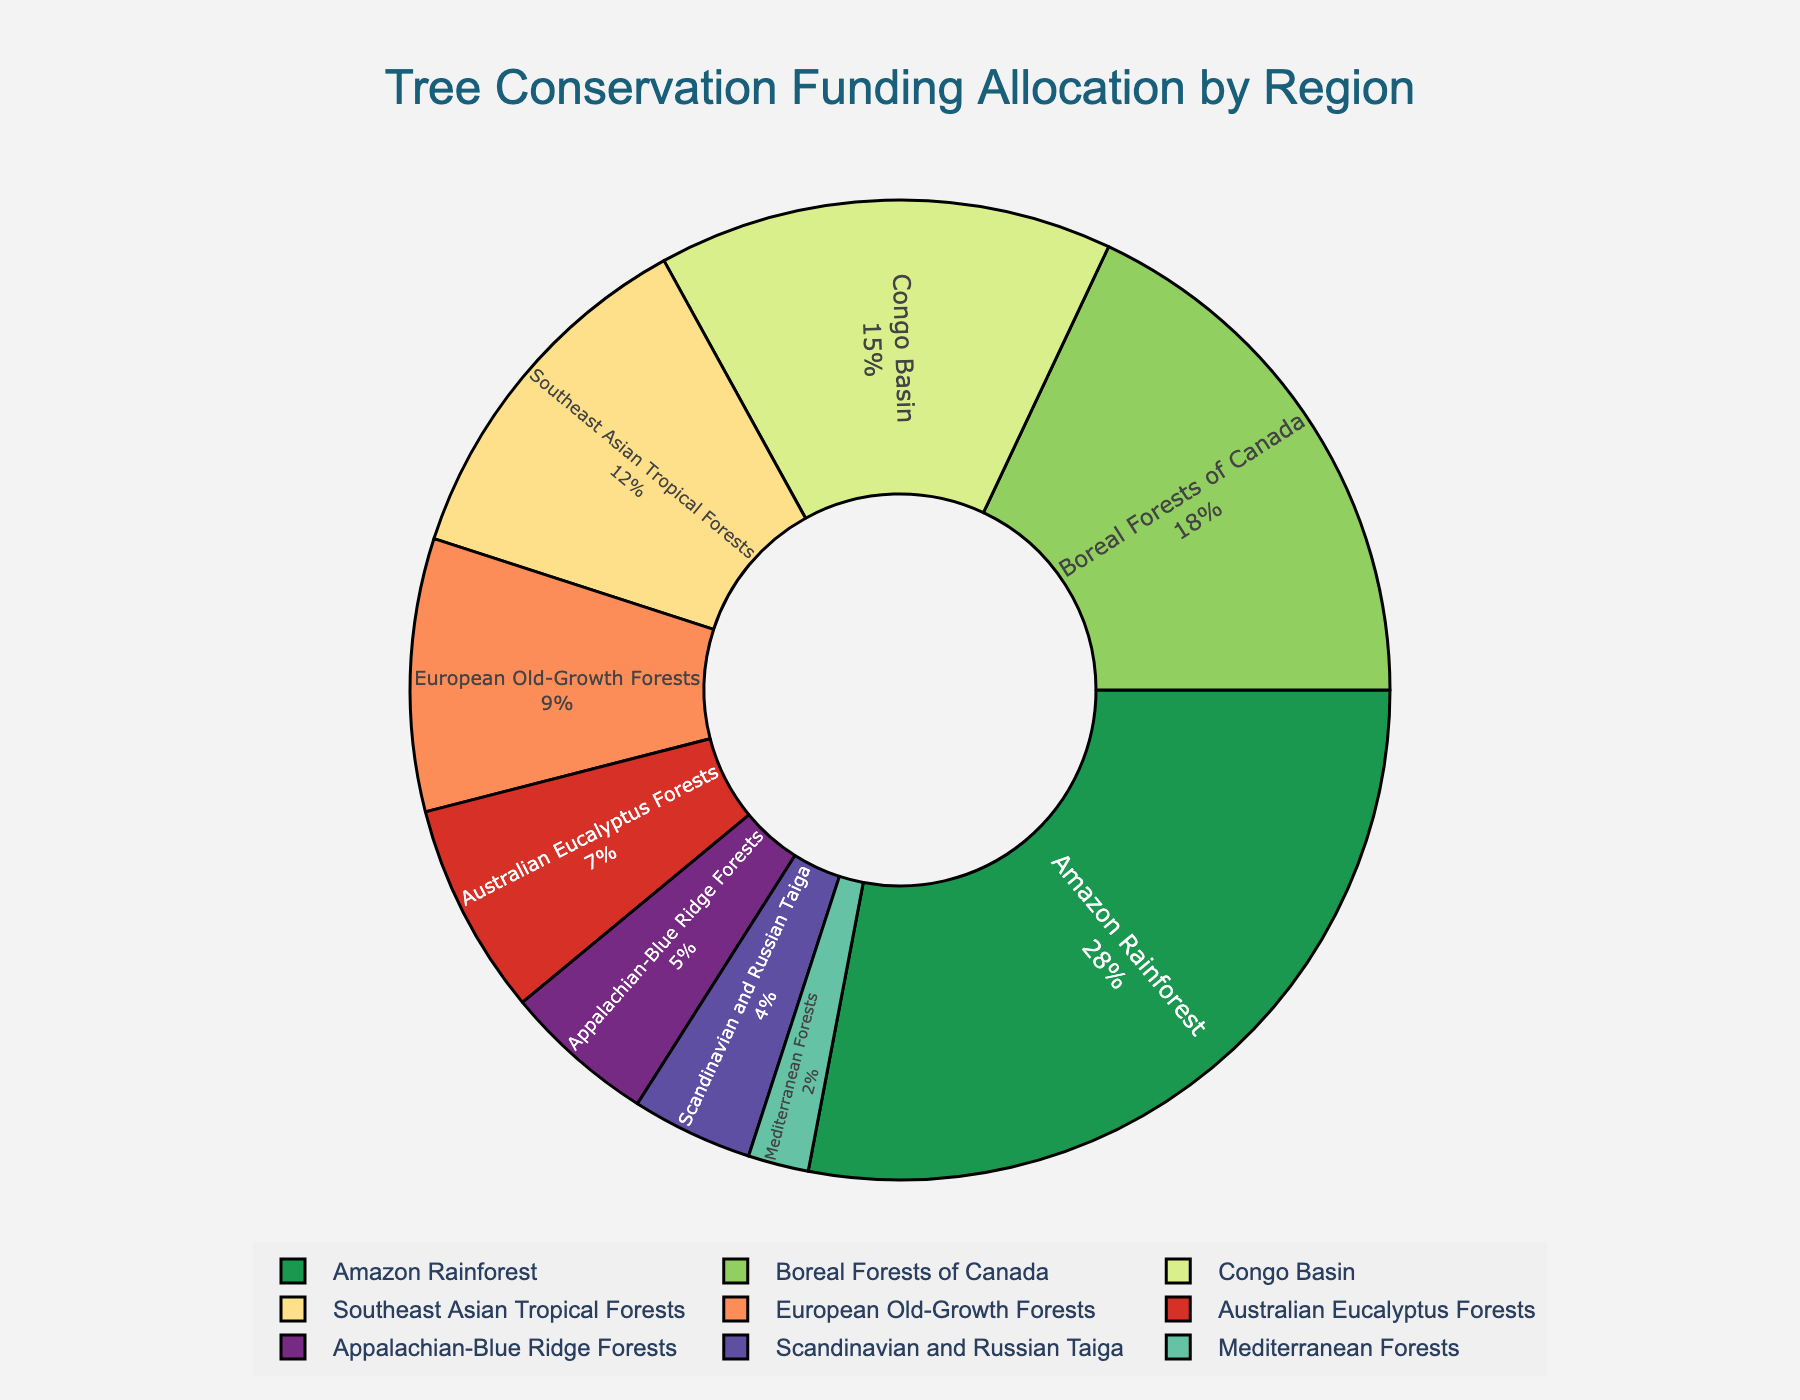What region receives the highest allocation of funding for tree conservation projects? The region with the highest allocation is shown at the largest segment of the pie chart.
Answer: Amazon Rainforest Which region receives more funding: the Congo Basin or the European Old-Growth Forests? Compare the size of the pie chart segments for the Congo Basin and the European Old-Growth Forests. The Congo Basin has a larger segment.
Answer: Congo Basin What is the total percentage of funding allocated to the Amazon Rainforest, Boreal Forests of Canada, and Southeast Asian Tropical Forests combined? Add the percentages for these regions: Amazon Rainforest (28%), Boreal Forests of Canada (18%), and Southeast Asian Tropical Forests (12%): 28 + 18 + 12 = 58%.
Answer: 58% If the percentage allocated to the Appalachian-Blue Ridge Forests doubled, would it surpass the funding allocated to the Boreal Forests of Canada? Doubling the current allocation for the Appalachian-Blue Ridge Forests (5%) gives 10%. Compare 10% with the Boreal Forests of Canada's 18%.
Answer: No Which two regions receive the least funding for tree conservation projects? Look for the two smallest segments in the pie chart, which are Mediterranean Forests (2%) and Scandinavian and Russian Taiga (4%).
Answer: Mediterranean Forests and Scandinavian and Russian Taiga By how much does the funding allocation for Southeast Asian Tropical Forests exceed that of the Australian Eucalyptus Forests? Subtract the percentage of Australian Eucalyptus Forests (7%) from Southeast Asian Tropical Forests (12%): 12 - 7 = 5%.
Answer: 5% Is the funding for the Appalachian-Blue Ridge Forests more than half of the allocation for European Old-Growth Forests? Half of the European Old-Growth Forests allocation (9%) is 4.5%. The Appalachian-Blue Ridge Forests allocation is 5%, which is more than 4.5%.
Answer: Yes What is the average funding allocation percentage for the Scandinavian and Russian Taiga, Mediterranean Forests, and Appalachian-Blue Ridge Forests? Add the percentages: Scandinavian and Russian Taiga (4%), Mediterranean Forests (2%), Appalachian-Blue Ridge Forests (5%), then divide by 3: (4 + 2 + 5) / 3 = 11 / 3 ≈ 3.67%.
Answer: 3.67% Does the total percentage of funding allocated to the Asian regions (Southeast Asian Tropical Forests) exceed 10%? The funding allocation for Southeast Asian Tropical Forests alone is 12%, which is greater than 10%.
Answer: Yes By what percentage does the Amazon Rainforest's allocation exceed that of the Boreal Forests of Canada? Subtract the percentage of Boreal Forests of Canada (18%) from Amazon Rainforest (28%): 28 - 18 = 10%.
Answer: 10% 